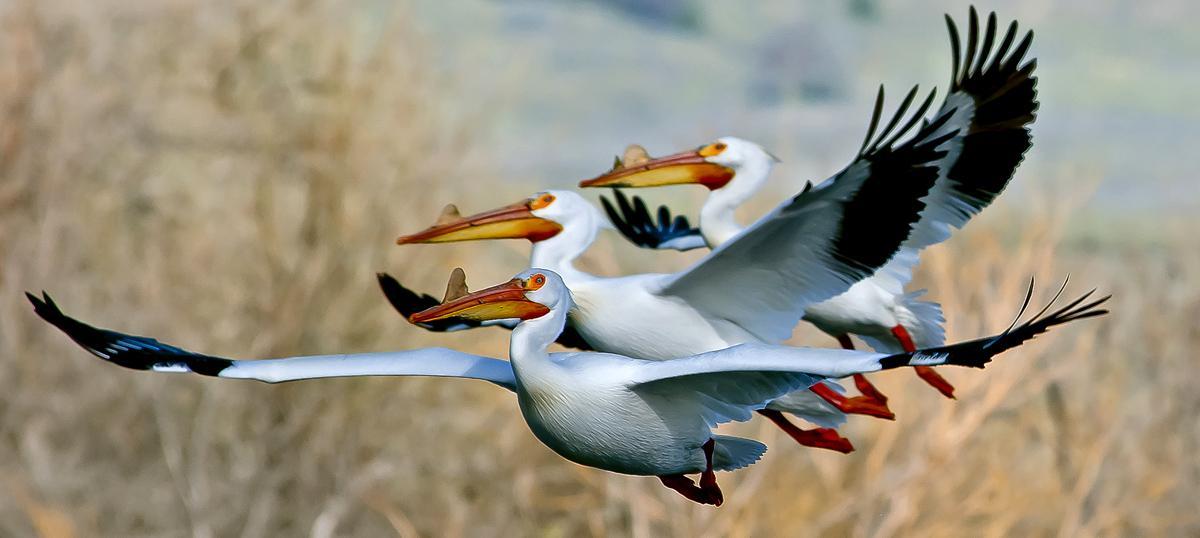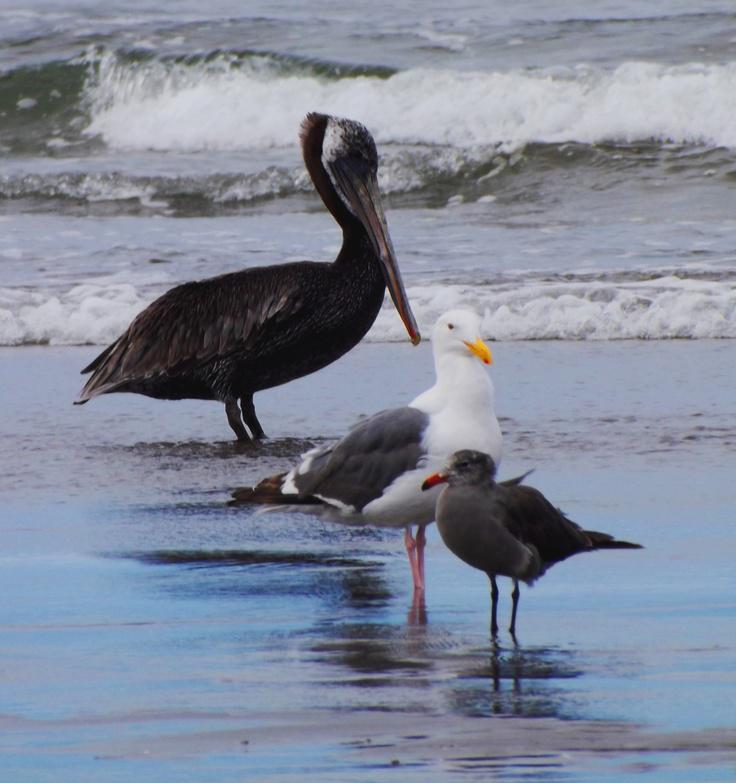The first image is the image on the left, the second image is the image on the right. Considering the images on both sides, is "The right image contains at least four birds." valid? Answer yes or no. No. The first image is the image on the left, the second image is the image on the right. Assess this claim about the two images: "there is a single pelican in flight". Correct or not? Answer yes or no. No. 